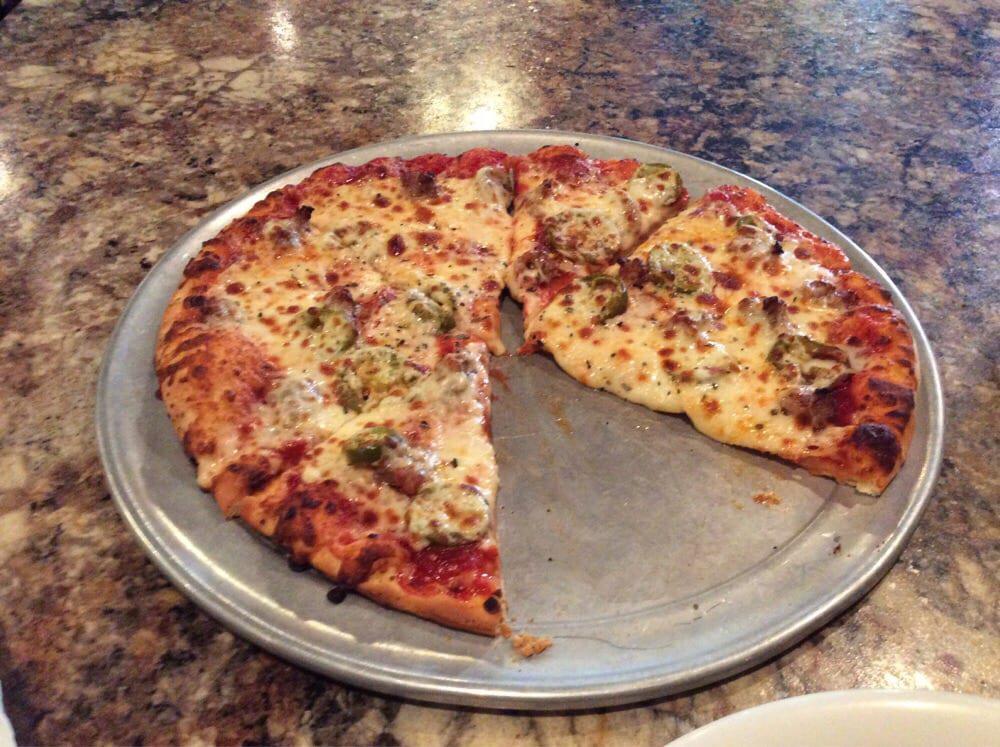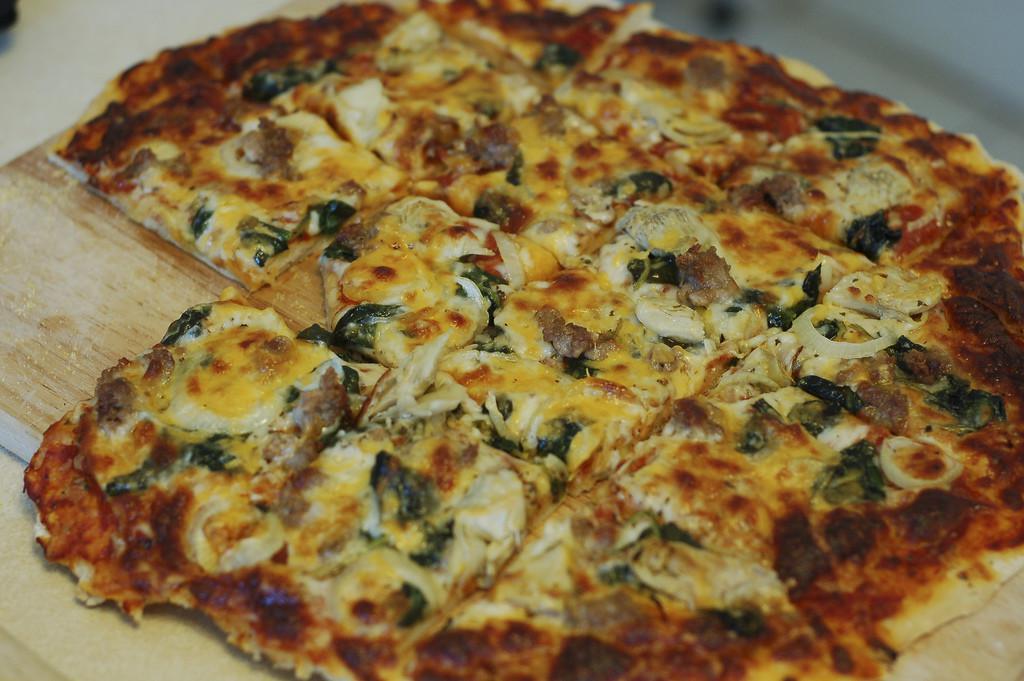The first image is the image on the left, the second image is the image on the right. Considering the images on both sides, is "One image shows a round pizza cut in triangular 'pie' slices, with a slice at least partly off, and the other image features a pizza cut in squares." valid? Answer yes or no. Yes. The first image is the image on the left, the second image is the image on the right. Assess this claim about the two images: "In one of the images the pizza is cut into squares.". Correct or not? Answer yes or no. Yes. 